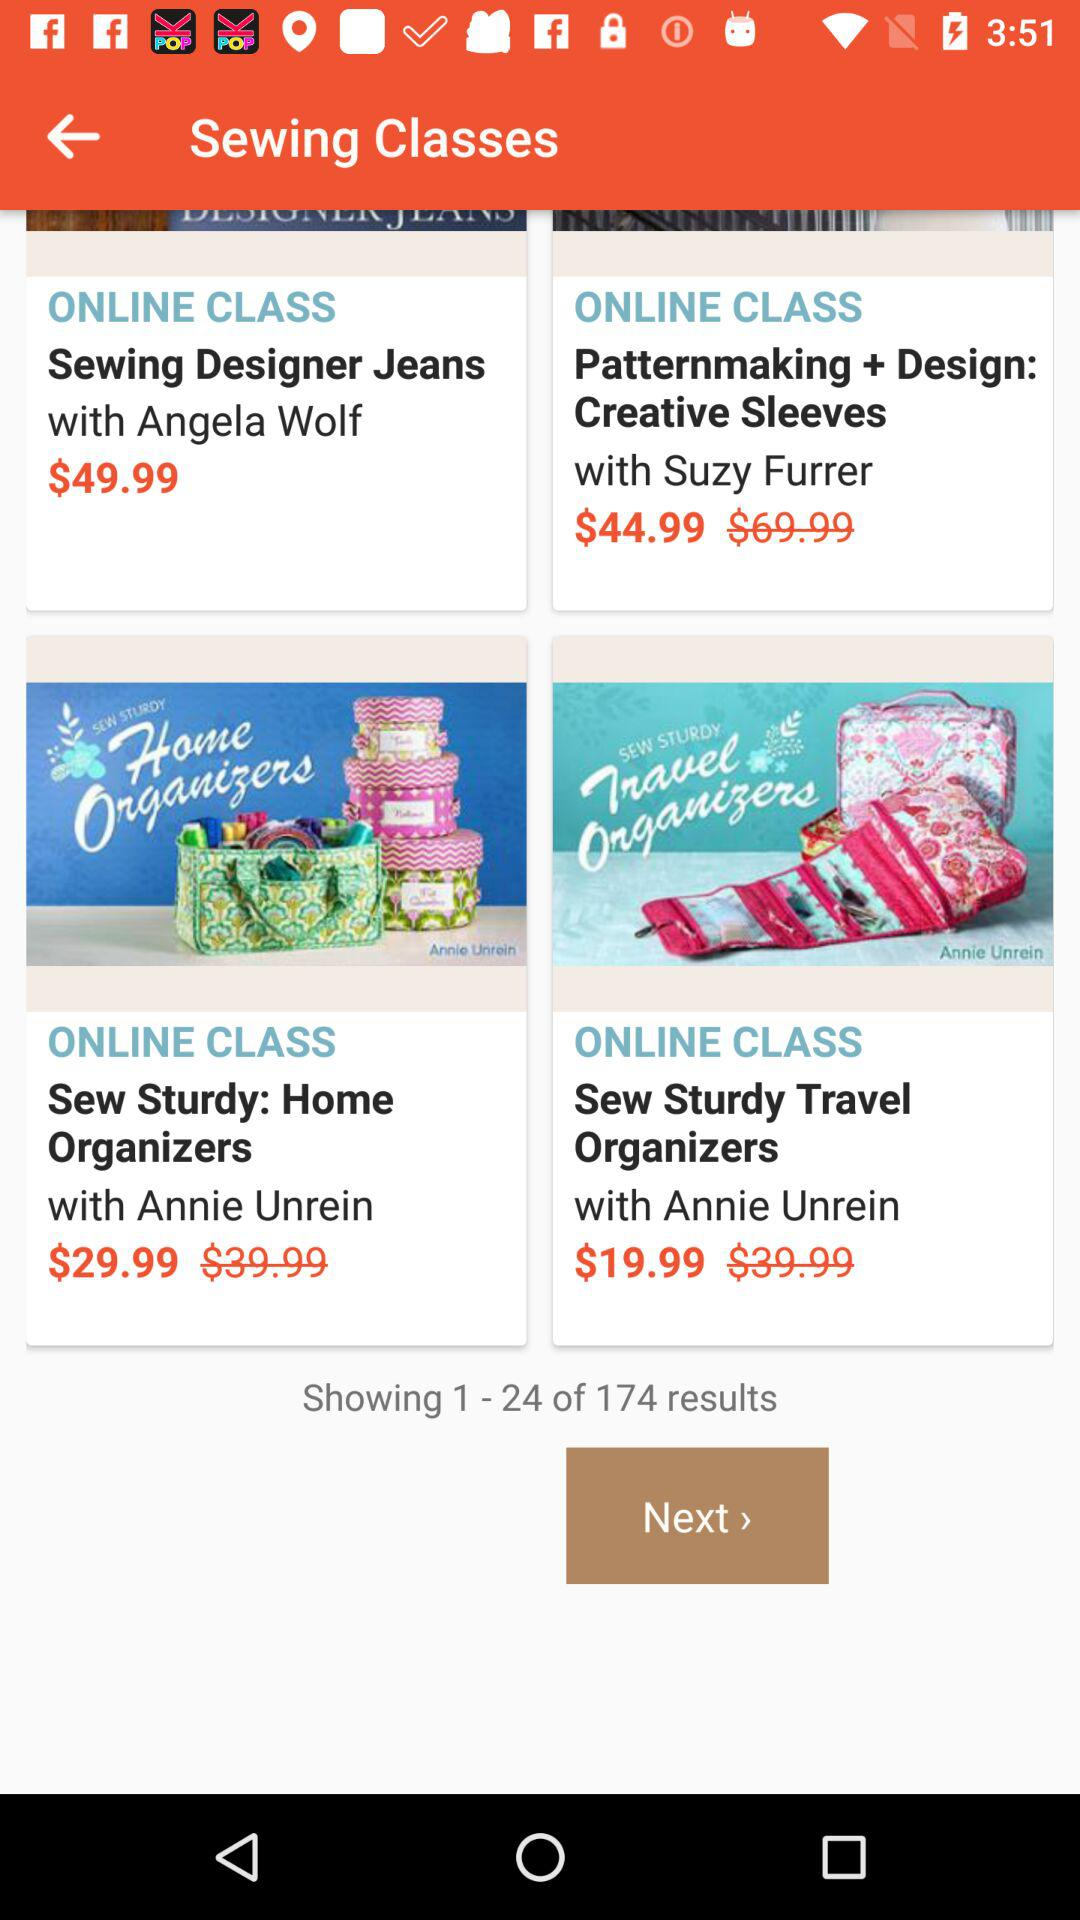What is the price of the online class "Home Organizers"? The price is $29.99. 